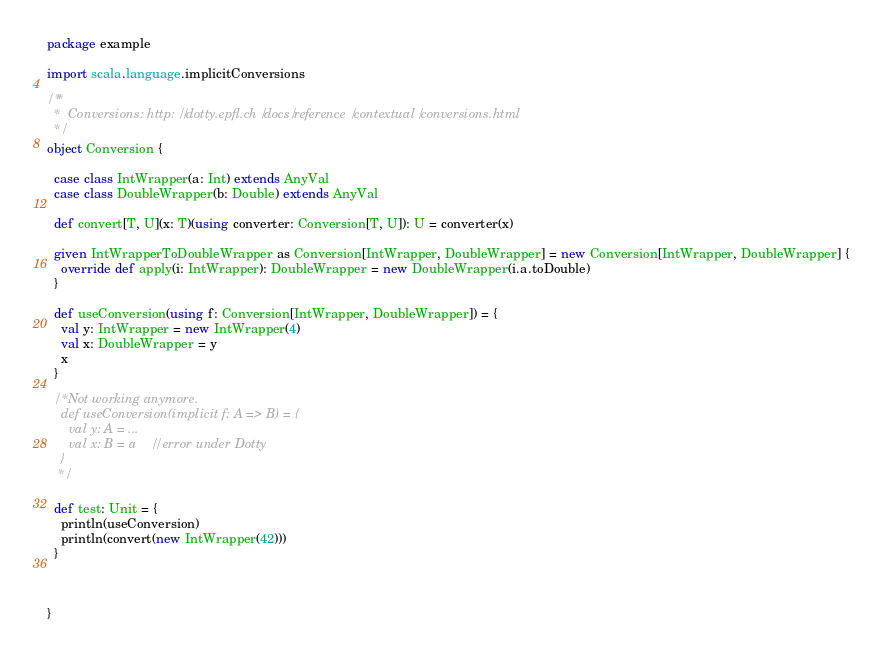<code> <loc_0><loc_0><loc_500><loc_500><_Scala_>package example

import scala.language.implicitConversions

/**
  *  Conversions: http://dotty.epfl.ch/docs/reference/contextual/conversions.html
  */
object Conversion {

  case class IntWrapper(a: Int) extends AnyVal
  case class DoubleWrapper(b: Double) extends AnyVal

  def convert[T, U](x: T)(using converter: Conversion[T, U]): U = converter(x)

  given IntWrapperToDoubleWrapper as Conversion[IntWrapper, DoubleWrapper] = new Conversion[IntWrapper, DoubleWrapper] {
    override def apply(i: IntWrapper): DoubleWrapper = new DoubleWrapper(i.a.toDouble)
  }

  def useConversion(using f: Conversion[IntWrapper, DoubleWrapper]) = {
    val y: IntWrapper = new IntWrapper(4)
    val x: DoubleWrapper = y
    x
  }

  /* Not working anymore.
    def useConversion(implicit f: A => B) = {
      val y: A = ...
      val x: B = a    // error under Dotty
    }
   */

  def test: Unit = {
    println(useConversion)
    println(convert(new IntWrapper(42)))
  }



}
</code> 